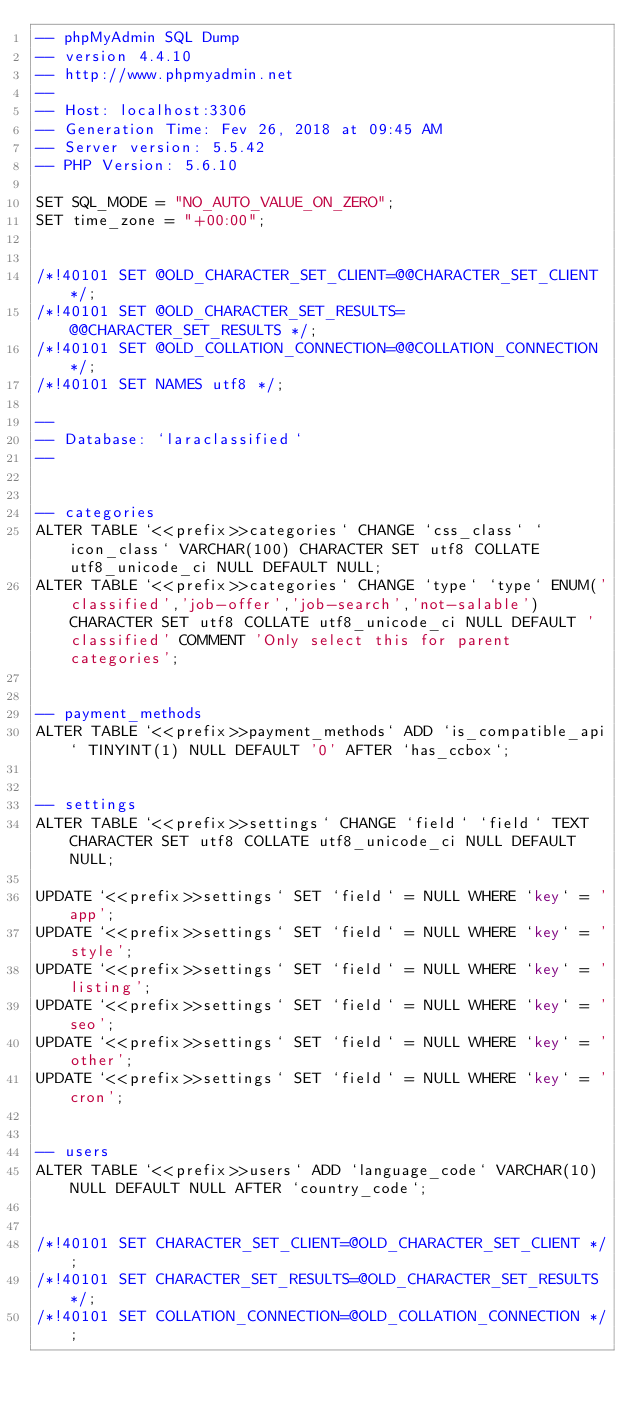<code> <loc_0><loc_0><loc_500><loc_500><_SQL_>-- phpMyAdmin SQL Dump
-- version 4.4.10
-- http://www.phpmyadmin.net
--
-- Host: localhost:3306
-- Generation Time: Fev 26, 2018 at 09:45 AM
-- Server version: 5.5.42
-- PHP Version: 5.6.10

SET SQL_MODE = "NO_AUTO_VALUE_ON_ZERO";
SET time_zone = "+00:00";


/*!40101 SET @OLD_CHARACTER_SET_CLIENT=@@CHARACTER_SET_CLIENT */;
/*!40101 SET @OLD_CHARACTER_SET_RESULTS=@@CHARACTER_SET_RESULTS */;
/*!40101 SET @OLD_COLLATION_CONNECTION=@@COLLATION_CONNECTION */;
/*!40101 SET NAMES utf8 */;

--
-- Database: `laraclassified`
--


-- categories
ALTER TABLE `<<prefix>>categories` CHANGE `css_class` `icon_class` VARCHAR(100) CHARACTER SET utf8 COLLATE utf8_unicode_ci NULL DEFAULT NULL;
ALTER TABLE `<<prefix>>categories` CHANGE `type` `type` ENUM('classified','job-offer','job-search','not-salable') CHARACTER SET utf8 COLLATE utf8_unicode_ci NULL DEFAULT 'classified' COMMENT 'Only select this for parent categories';


-- payment_methods
ALTER TABLE `<<prefix>>payment_methods` ADD `is_compatible_api` TINYINT(1) NULL DEFAULT '0' AFTER `has_ccbox`;


-- settings
ALTER TABLE `<<prefix>>settings` CHANGE `field` `field` TEXT CHARACTER SET utf8 COLLATE utf8_unicode_ci NULL DEFAULT NULL;

UPDATE `<<prefix>>settings` SET `field` = NULL WHERE `key` = 'app';
UPDATE `<<prefix>>settings` SET `field` = NULL WHERE `key` = 'style';
UPDATE `<<prefix>>settings` SET `field` = NULL WHERE `key` = 'listing';
UPDATE `<<prefix>>settings` SET `field` = NULL WHERE `key` = 'seo';
UPDATE `<<prefix>>settings` SET `field` = NULL WHERE `key` = 'other';
UPDATE `<<prefix>>settings` SET `field` = NULL WHERE `key` = 'cron';


-- users
ALTER TABLE `<<prefix>>users` ADD `language_code` VARCHAR(10) NULL DEFAULT NULL AFTER `country_code`;


/*!40101 SET CHARACTER_SET_CLIENT=@OLD_CHARACTER_SET_CLIENT */;
/*!40101 SET CHARACTER_SET_RESULTS=@OLD_CHARACTER_SET_RESULTS */;
/*!40101 SET COLLATION_CONNECTION=@OLD_COLLATION_CONNECTION */;</code> 